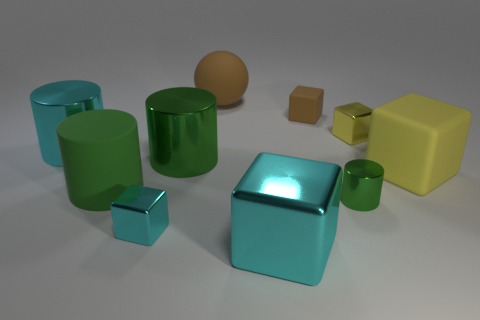Are there any tiny yellow cubes that have the same material as the small green object?
Provide a succinct answer. Yes. The big rubber thing that is both behind the large green rubber thing and on the left side of the big yellow rubber object has what shape?
Provide a succinct answer. Sphere. What number of tiny things are green rubber cylinders or cyan cylinders?
Provide a short and direct response. 0. What is the tiny brown cube made of?
Ensure brevity in your answer.  Rubber. How many other things are there of the same shape as the small brown matte thing?
Offer a very short reply. 4. What size is the brown rubber cube?
Ensure brevity in your answer.  Small. What size is the block that is both in front of the yellow metallic block and on the right side of the small matte block?
Give a very brief answer. Large. The small object that is on the right side of the tiny green thing has what shape?
Provide a succinct answer. Cube. Do the small cyan object and the big block left of the small yellow shiny block have the same material?
Make the answer very short. Yes. Does the tiny yellow thing have the same shape as the large brown matte object?
Give a very brief answer. No. 